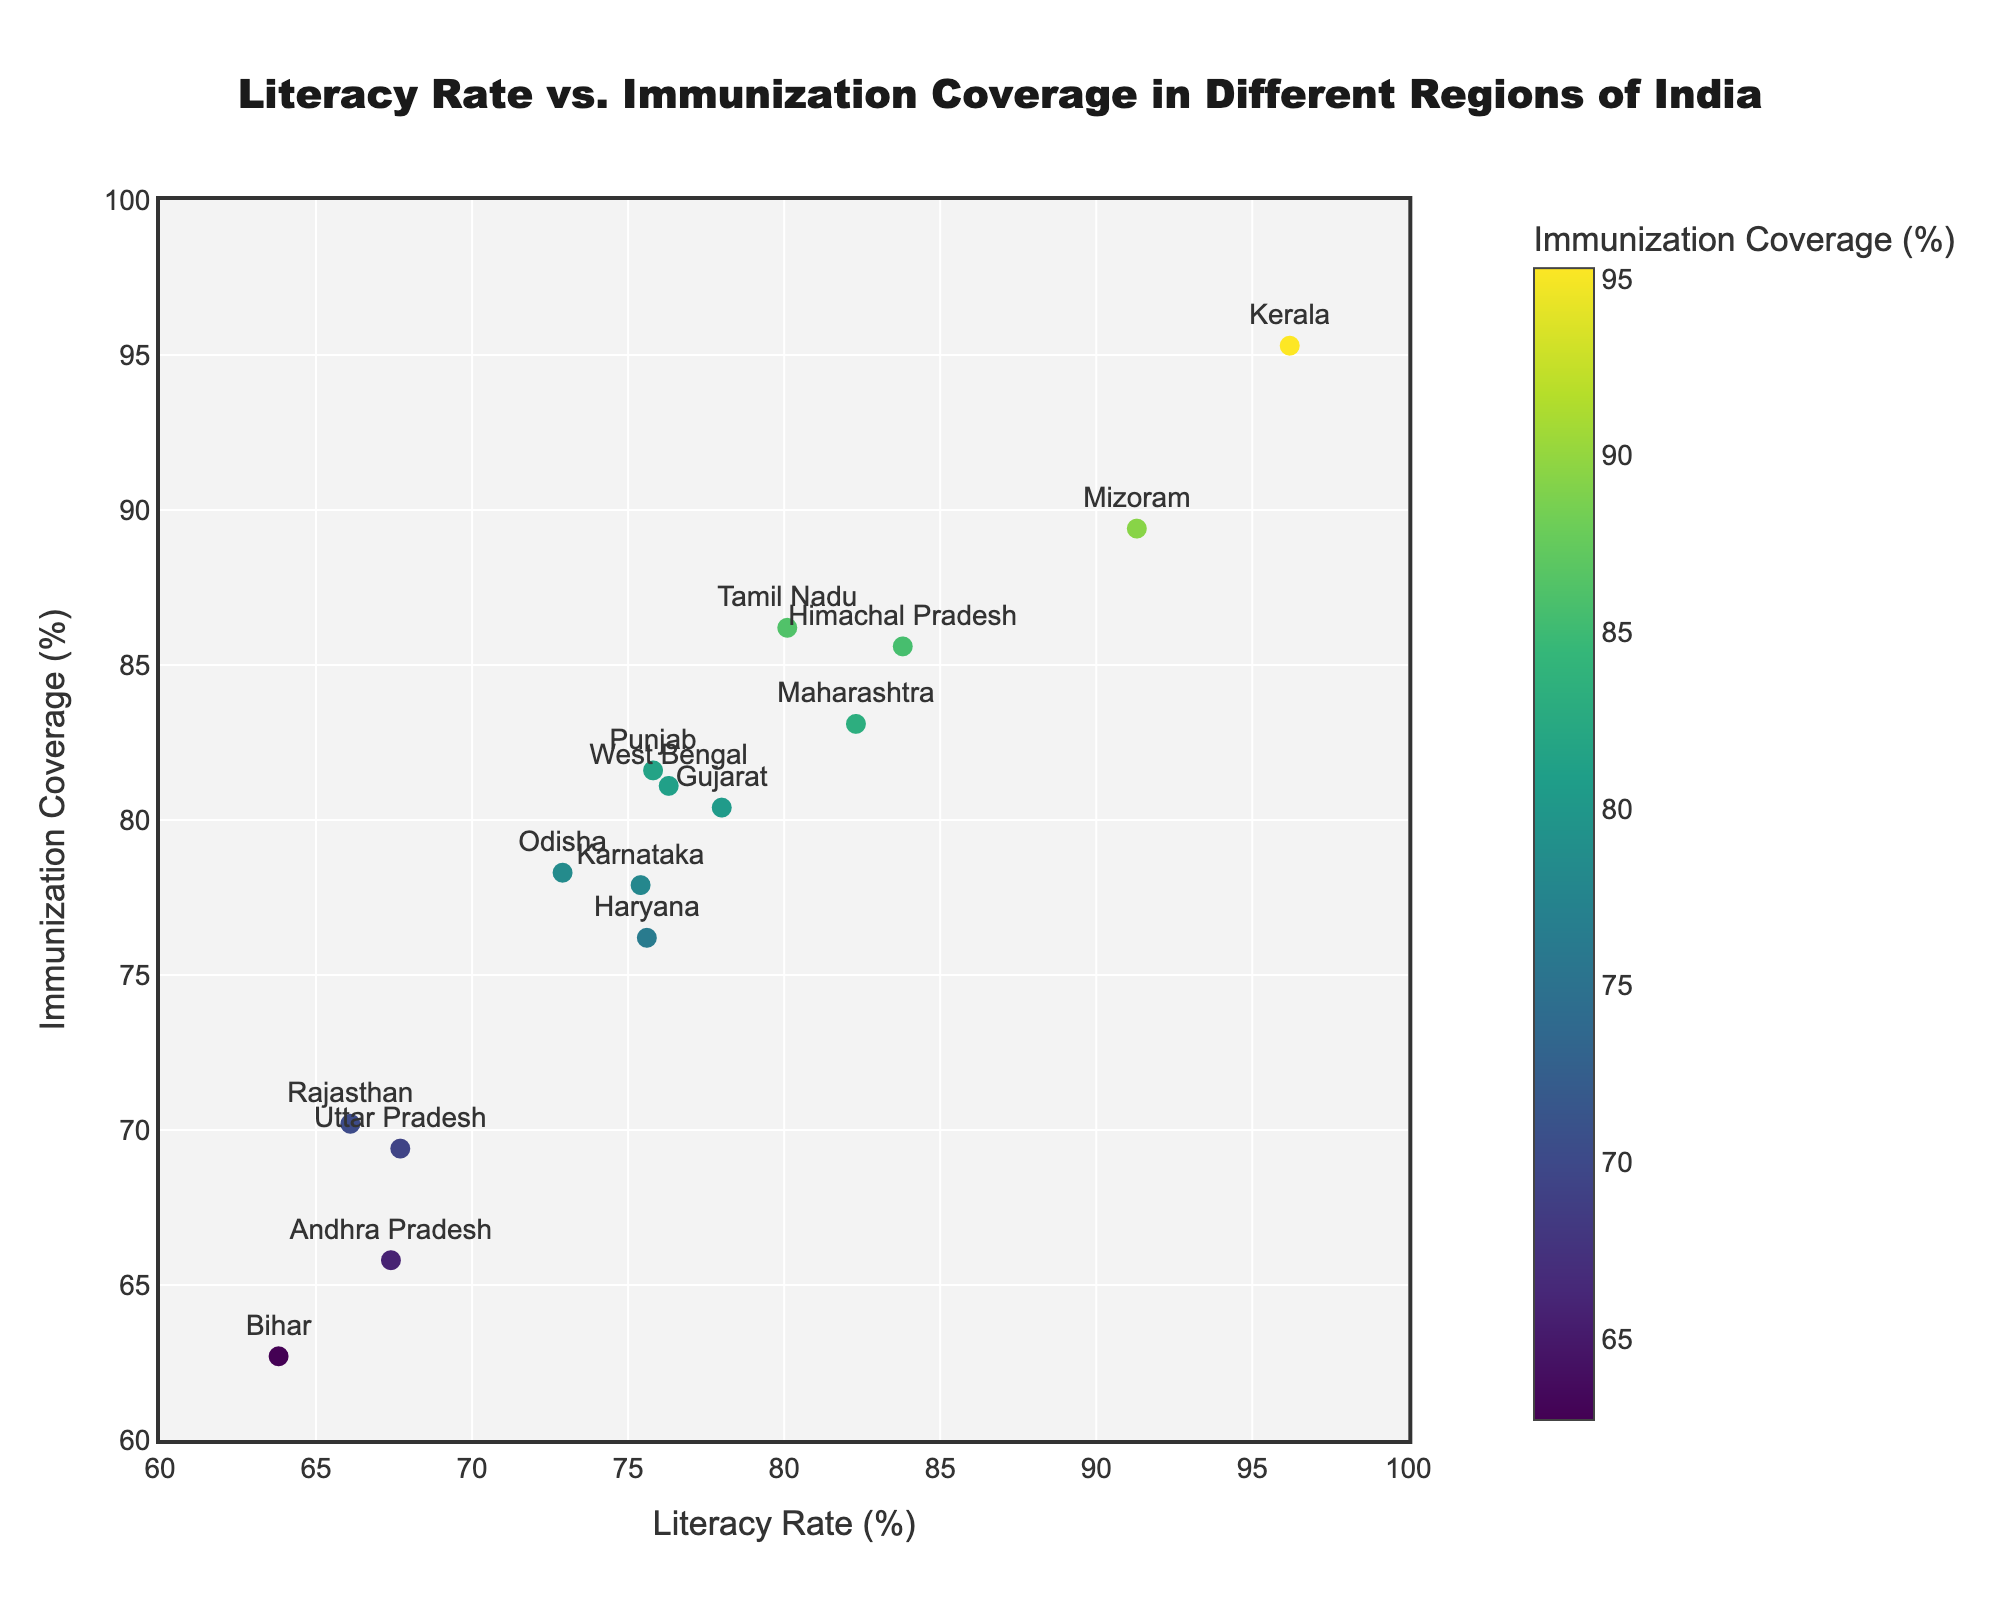What is the title of the scatter plot? The title of the figure is prominently displayed at the top in larger font size. It reads "Literacy Rate vs. Immunization Coverage in Different Regions of India".
Answer: Literacy Rate vs. Immunization Coverage in Different Regions of India What is the literacy rate in Kerala? Each data point is labeled with the region's name, and hovering over Kerala's point shows the exact literacy rate. The literacy rate for Kerala is shown as 96.2%.
Answer: 96.2% Which region has the highest immunization coverage? The markers' hover information in the scatter plot includes both literacy rates and immunization coverage. By observing, Kerala has the highest immunization coverage at 95.3%.
Answer: Kerala How many regions have an immunization coverage greater than 80%? By counting the data points where the y-axis value (immunization coverage) is greater than 80%, we see that there are seven regions: Kerala, Mizoram, Himachal Pradesh, Tamil Nadu, Maharashtra, Punjab, and West Bengal.
Answer: 7 Is there a positive correlation between literacy rate and immunization coverage? Observing the trend of the data points, higher literacy rates generally appear to be associated with higher immunization coverage, indicating a positive correlation.
Answer: Yes Which region has the lowest literacy rate and what is its immunization coverage? By identifying the data point with the lowest x-axis value for literacy rate, Bihar is the region, and its hover information shows an immunization coverage of 62.7%.
Answer: Bihar, 62.7% Between Himachal Pradesh and Karnataka, which region has a higher literacy rate and by how much? Himachal Pradesh has a literacy rate of 83.8%, compared to Karnataka's 75.4%. The difference can be calculated as 83.8 - 75.4 = 8.4%.
Answer: Himachal Pradesh, 8.4% Calculate the average immunization coverage for the regions: Andhra Pradesh, Uttar Pradesh, and Bihar. The immunization coverages are 65.8% for Andhra Pradesh, 69.4% for Uttar Pradesh, and 62.7% for Bihar. The average is (65.8 + 69.4 + 62.7) / 3 = 65.97%.
Answer: 65.97% Which region has a better balance between literacy rate and immunization coverage, Maharashtra or Andhra Pradesh? Maharashtra's literacy rate is 82.3% and its immunization coverage is 83.1%, while Andhra Pradesh's values are 67.4% and 65.8%, respectively. Maharashtra has higher values in both metrics, showing a better balance.
Answer: Maharashtra 